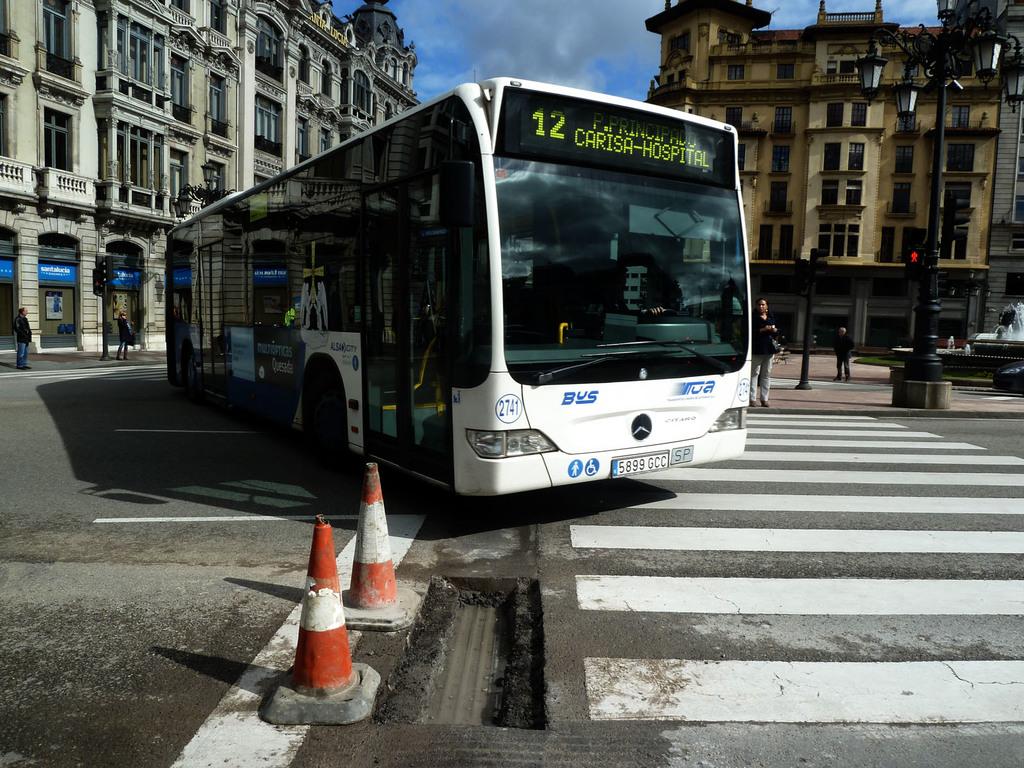What bus number is this?
Provide a succinct answer. 12. Where is the bus going?
Make the answer very short. Carisa-hospital. 